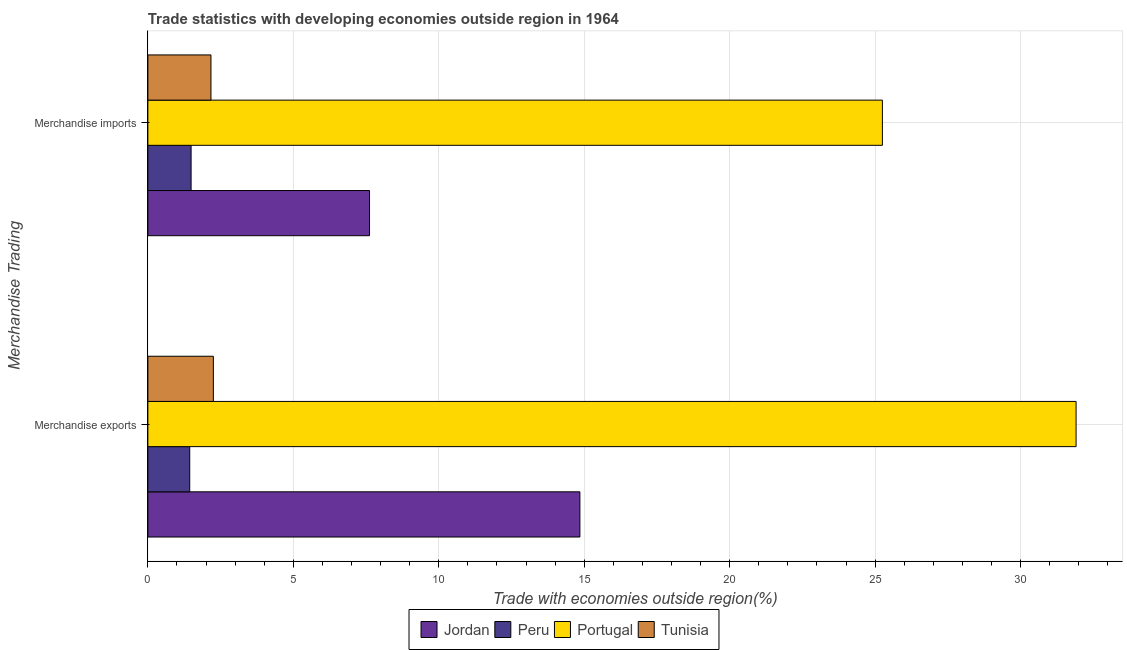How many different coloured bars are there?
Give a very brief answer. 4. How many groups of bars are there?
Offer a very short reply. 2. What is the merchandise exports in Portugal?
Keep it short and to the point. 31.91. Across all countries, what is the maximum merchandise exports?
Offer a very short reply. 31.91. Across all countries, what is the minimum merchandise exports?
Your answer should be compact. 1.44. What is the total merchandise imports in the graph?
Ensure brevity in your answer.  36.53. What is the difference between the merchandise exports in Jordan and that in Tunisia?
Offer a terse response. 12.6. What is the difference between the merchandise exports in Jordan and the merchandise imports in Portugal?
Give a very brief answer. -10.4. What is the average merchandise exports per country?
Provide a succinct answer. 12.61. What is the difference between the merchandise exports and merchandise imports in Jordan?
Ensure brevity in your answer.  7.23. In how many countries, is the merchandise imports greater than 3 %?
Ensure brevity in your answer.  2. What is the ratio of the merchandise exports in Peru to that in Tunisia?
Give a very brief answer. 0.64. Is the merchandise exports in Jordan less than that in Tunisia?
Make the answer very short. No. What does the 1st bar from the top in Merchandise imports represents?
Your answer should be compact. Tunisia. What does the 2nd bar from the bottom in Merchandise exports represents?
Provide a short and direct response. Peru. Are all the bars in the graph horizontal?
Your answer should be compact. Yes. What is the difference between two consecutive major ticks on the X-axis?
Ensure brevity in your answer.  5. How many legend labels are there?
Your answer should be very brief. 4. What is the title of the graph?
Make the answer very short. Trade statistics with developing economies outside region in 1964. What is the label or title of the X-axis?
Keep it short and to the point. Trade with economies outside region(%). What is the label or title of the Y-axis?
Offer a terse response. Merchandise Trading. What is the Trade with economies outside region(%) of Jordan in Merchandise exports?
Make the answer very short. 14.85. What is the Trade with economies outside region(%) in Peru in Merchandise exports?
Your answer should be very brief. 1.44. What is the Trade with economies outside region(%) in Portugal in Merchandise exports?
Make the answer very short. 31.91. What is the Trade with economies outside region(%) of Tunisia in Merchandise exports?
Give a very brief answer. 2.25. What is the Trade with economies outside region(%) in Jordan in Merchandise imports?
Keep it short and to the point. 7.62. What is the Trade with economies outside region(%) of Peru in Merchandise imports?
Your answer should be very brief. 1.49. What is the Trade with economies outside region(%) in Portugal in Merchandise imports?
Give a very brief answer. 25.25. What is the Trade with economies outside region(%) in Tunisia in Merchandise imports?
Keep it short and to the point. 2.17. Across all Merchandise Trading, what is the maximum Trade with economies outside region(%) of Jordan?
Offer a terse response. 14.85. Across all Merchandise Trading, what is the maximum Trade with economies outside region(%) in Peru?
Make the answer very short. 1.49. Across all Merchandise Trading, what is the maximum Trade with economies outside region(%) of Portugal?
Keep it short and to the point. 31.91. Across all Merchandise Trading, what is the maximum Trade with economies outside region(%) of Tunisia?
Provide a short and direct response. 2.25. Across all Merchandise Trading, what is the minimum Trade with economies outside region(%) in Jordan?
Give a very brief answer. 7.62. Across all Merchandise Trading, what is the minimum Trade with economies outside region(%) of Peru?
Your response must be concise. 1.44. Across all Merchandise Trading, what is the minimum Trade with economies outside region(%) of Portugal?
Your answer should be very brief. 25.25. Across all Merchandise Trading, what is the minimum Trade with economies outside region(%) of Tunisia?
Provide a succinct answer. 2.17. What is the total Trade with economies outside region(%) of Jordan in the graph?
Your answer should be very brief. 22.47. What is the total Trade with economies outside region(%) of Peru in the graph?
Your answer should be very brief. 2.92. What is the total Trade with economies outside region(%) of Portugal in the graph?
Your answer should be compact. 57.16. What is the total Trade with economies outside region(%) in Tunisia in the graph?
Provide a short and direct response. 4.42. What is the difference between the Trade with economies outside region(%) of Jordan in Merchandise exports and that in Merchandise imports?
Provide a succinct answer. 7.23. What is the difference between the Trade with economies outside region(%) of Peru in Merchandise exports and that in Merchandise imports?
Make the answer very short. -0.05. What is the difference between the Trade with economies outside region(%) in Portugal in Merchandise exports and that in Merchandise imports?
Offer a very short reply. 6.66. What is the difference between the Trade with economies outside region(%) of Tunisia in Merchandise exports and that in Merchandise imports?
Provide a short and direct response. 0.08. What is the difference between the Trade with economies outside region(%) of Jordan in Merchandise exports and the Trade with economies outside region(%) of Peru in Merchandise imports?
Your answer should be very brief. 13.37. What is the difference between the Trade with economies outside region(%) of Jordan in Merchandise exports and the Trade with economies outside region(%) of Portugal in Merchandise imports?
Offer a terse response. -10.4. What is the difference between the Trade with economies outside region(%) of Jordan in Merchandise exports and the Trade with economies outside region(%) of Tunisia in Merchandise imports?
Your answer should be very brief. 12.68. What is the difference between the Trade with economies outside region(%) in Peru in Merchandise exports and the Trade with economies outside region(%) in Portugal in Merchandise imports?
Provide a succinct answer. -23.81. What is the difference between the Trade with economies outside region(%) of Peru in Merchandise exports and the Trade with economies outside region(%) of Tunisia in Merchandise imports?
Your response must be concise. -0.73. What is the difference between the Trade with economies outside region(%) of Portugal in Merchandise exports and the Trade with economies outside region(%) of Tunisia in Merchandise imports?
Offer a terse response. 29.74. What is the average Trade with economies outside region(%) in Jordan per Merchandise Trading?
Your response must be concise. 11.24. What is the average Trade with economies outside region(%) of Peru per Merchandise Trading?
Keep it short and to the point. 1.46. What is the average Trade with economies outside region(%) in Portugal per Merchandise Trading?
Your answer should be very brief. 28.58. What is the average Trade with economies outside region(%) of Tunisia per Merchandise Trading?
Your answer should be compact. 2.21. What is the difference between the Trade with economies outside region(%) in Jordan and Trade with economies outside region(%) in Peru in Merchandise exports?
Offer a very short reply. 13.41. What is the difference between the Trade with economies outside region(%) of Jordan and Trade with economies outside region(%) of Portugal in Merchandise exports?
Offer a terse response. -17.06. What is the difference between the Trade with economies outside region(%) in Jordan and Trade with economies outside region(%) in Tunisia in Merchandise exports?
Your response must be concise. 12.6. What is the difference between the Trade with economies outside region(%) in Peru and Trade with economies outside region(%) in Portugal in Merchandise exports?
Offer a terse response. -30.47. What is the difference between the Trade with economies outside region(%) in Peru and Trade with economies outside region(%) in Tunisia in Merchandise exports?
Provide a succinct answer. -0.81. What is the difference between the Trade with economies outside region(%) of Portugal and Trade with economies outside region(%) of Tunisia in Merchandise exports?
Provide a short and direct response. 29.66. What is the difference between the Trade with economies outside region(%) of Jordan and Trade with economies outside region(%) of Peru in Merchandise imports?
Your answer should be very brief. 6.13. What is the difference between the Trade with economies outside region(%) of Jordan and Trade with economies outside region(%) of Portugal in Merchandise imports?
Your response must be concise. -17.63. What is the difference between the Trade with economies outside region(%) of Jordan and Trade with economies outside region(%) of Tunisia in Merchandise imports?
Offer a very short reply. 5.45. What is the difference between the Trade with economies outside region(%) of Peru and Trade with economies outside region(%) of Portugal in Merchandise imports?
Offer a terse response. -23.76. What is the difference between the Trade with economies outside region(%) of Peru and Trade with economies outside region(%) of Tunisia in Merchandise imports?
Offer a very short reply. -0.68. What is the difference between the Trade with economies outside region(%) of Portugal and Trade with economies outside region(%) of Tunisia in Merchandise imports?
Ensure brevity in your answer.  23.08. What is the ratio of the Trade with economies outside region(%) of Jordan in Merchandise exports to that in Merchandise imports?
Provide a succinct answer. 1.95. What is the ratio of the Trade with economies outside region(%) of Peru in Merchandise exports to that in Merchandise imports?
Provide a succinct answer. 0.97. What is the ratio of the Trade with economies outside region(%) of Portugal in Merchandise exports to that in Merchandise imports?
Your answer should be very brief. 1.26. What is the ratio of the Trade with economies outside region(%) of Tunisia in Merchandise exports to that in Merchandise imports?
Offer a very short reply. 1.04. What is the difference between the highest and the second highest Trade with economies outside region(%) in Jordan?
Ensure brevity in your answer.  7.23. What is the difference between the highest and the second highest Trade with economies outside region(%) in Peru?
Make the answer very short. 0.05. What is the difference between the highest and the second highest Trade with economies outside region(%) of Portugal?
Keep it short and to the point. 6.66. What is the difference between the highest and the second highest Trade with economies outside region(%) in Tunisia?
Offer a very short reply. 0.08. What is the difference between the highest and the lowest Trade with economies outside region(%) in Jordan?
Make the answer very short. 7.23. What is the difference between the highest and the lowest Trade with economies outside region(%) of Peru?
Offer a very short reply. 0.05. What is the difference between the highest and the lowest Trade with economies outside region(%) in Portugal?
Make the answer very short. 6.66. What is the difference between the highest and the lowest Trade with economies outside region(%) in Tunisia?
Keep it short and to the point. 0.08. 